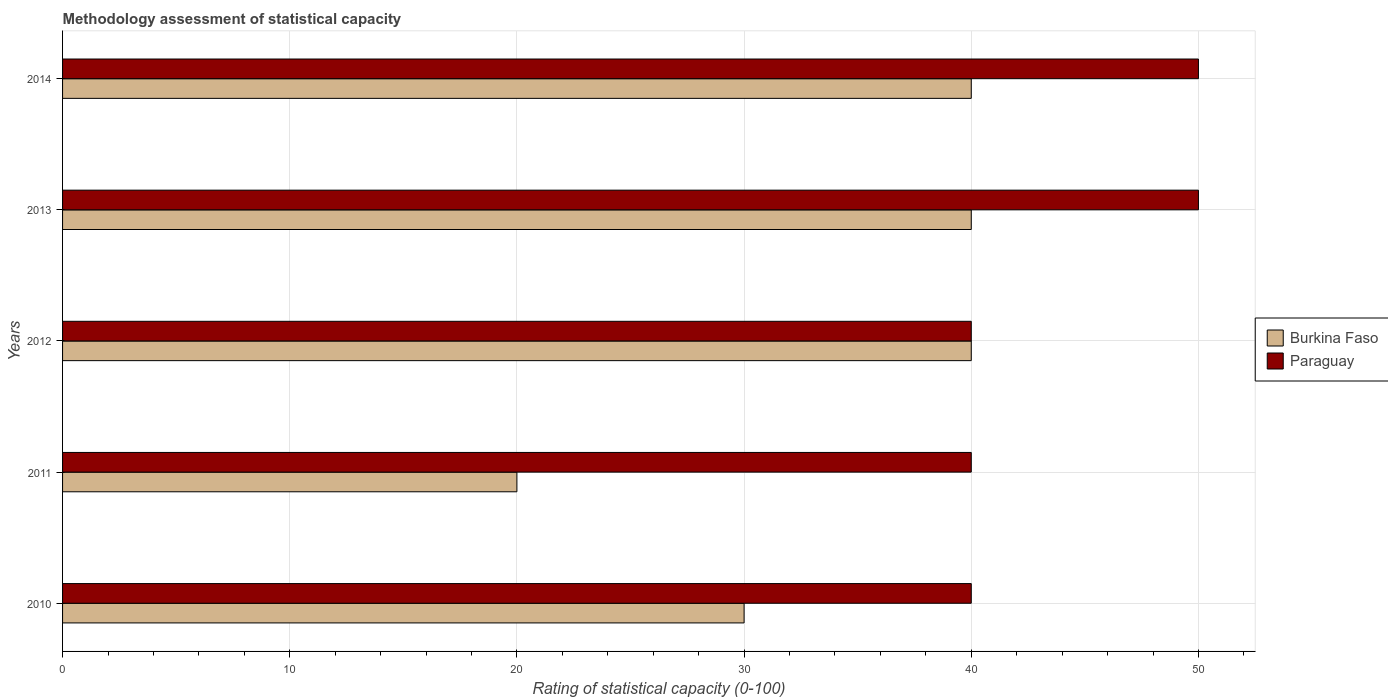Are the number of bars per tick equal to the number of legend labels?
Your answer should be very brief. Yes. Are the number of bars on each tick of the Y-axis equal?
Provide a succinct answer. Yes. How many bars are there on the 3rd tick from the bottom?
Your answer should be compact. 2. What is the label of the 2nd group of bars from the top?
Your answer should be very brief. 2013. What is the rating of statistical capacity in Paraguay in 2011?
Offer a terse response. 40. Across all years, what is the maximum rating of statistical capacity in Burkina Faso?
Your response must be concise. 40. Across all years, what is the minimum rating of statistical capacity in Burkina Faso?
Make the answer very short. 20. In which year was the rating of statistical capacity in Paraguay maximum?
Give a very brief answer. 2013. What is the total rating of statistical capacity in Paraguay in the graph?
Offer a very short reply. 220. What is the difference between the rating of statistical capacity in Paraguay in 2010 and that in 2014?
Provide a succinct answer. -10. What is the difference between the rating of statistical capacity in Paraguay in 2010 and the rating of statistical capacity in Burkina Faso in 2012?
Your response must be concise. 0. What is the average rating of statistical capacity in Paraguay per year?
Your response must be concise. 44. In the year 2013, what is the difference between the rating of statistical capacity in Paraguay and rating of statistical capacity in Burkina Faso?
Your response must be concise. 10. What is the ratio of the rating of statistical capacity in Burkina Faso in 2010 to that in 2014?
Provide a short and direct response. 0.75. Is the difference between the rating of statistical capacity in Paraguay in 2011 and 2013 greater than the difference between the rating of statistical capacity in Burkina Faso in 2011 and 2013?
Your answer should be compact. Yes. What is the difference between the highest and the second highest rating of statistical capacity in Burkina Faso?
Keep it short and to the point. 0. What is the difference between the highest and the lowest rating of statistical capacity in Paraguay?
Offer a very short reply. 10. Is the sum of the rating of statistical capacity in Paraguay in 2012 and 2013 greater than the maximum rating of statistical capacity in Burkina Faso across all years?
Offer a terse response. Yes. What does the 2nd bar from the top in 2014 represents?
Give a very brief answer. Burkina Faso. What does the 2nd bar from the bottom in 2014 represents?
Offer a very short reply. Paraguay. How many bars are there?
Make the answer very short. 10. How many years are there in the graph?
Your answer should be compact. 5. What is the difference between two consecutive major ticks on the X-axis?
Make the answer very short. 10. Are the values on the major ticks of X-axis written in scientific E-notation?
Your answer should be very brief. No. Does the graph contain any zero values?
Offer a terse response. No. What is the title of the graph?
Keep it short and to the point. Methodology assessment of statistical capacity. Does "United Kingdom" appear as one of the legend labels in the graph?
Your response must be concise. No. What is the label or title of the X-axis?
Provide a succinct answer. Rating of statistical capacity (0-100). What is the label or title of the Y-axis?
Give a very brief answer. Years. What is the Rating of statistical capacity (0-100) in Paraguay in 2010?
Offer a very short reply. 40. What is the Rating of statistical capacity (0-100) in Paraguay in 2011?
Your answer should be compact. 40. What is the Rating of statistical capacity (0-100) in Burkina Faso in 2012?
Your answer should be very brief. 40. What is the Rating of statistical capacity (0-100) of Paraguay in 2012?
Your response must be concise. 40. What is the Rating of statistical capacity (0-100) of Burkina Faso in 2014?
Ensure brevity in your answer.  40. Across all years, what is the maximum Rating of statistical capacity (0-100) of Burkina Faso?
Your response must be concise. 40. Across all years, what is the maximum Rating of statistical capacity (0-100) in Paraguay?
Your answer should be very brief. 50. What is the total Rating of statistical capacity (0-100) of Burkina Faso in the graph?
Your answer should be compact. 170. What is the total Rating of statistical capacity (0-100) in Paraguay in the graph?
Give a very brief answer. 220. What is the difference between the Rating of statistical capacity (0-100) of Paraguay in 2010 and that in 2011?
Give a very brief answer. 0. What is the difference between the Rating of statistical capacity (0-100) in Paraguay in 2010 and that in 2012?
Ensure brevity in your answer.  0. What is the difference between the Rating of statistical capacity (0-100) in Burkina Faso in 2010 and that in 2013?
Ensure brevity in your answer.  -10. What is the difference between the Rating of statistical capacity (0-100) in Paraguay in 2010 and that in 2014?
Offer a very short reply. -10. What is the difference between the Rating of statistical capacity (0-100) in Burkina Faso in 2011 and that in 2012?
Your response must be concise. -20. What is the difference between the Rating of statistical capacity (0-100) of Burkina Faso in 2012 and that in 2013?
Give a very brief answer. 0. What is the difference between the Rating of statistical capacity (0-100) of Burkina Faso in 2012 and that in 2014?
Ensure brevity in your answer.  0. What is the difference between the Rating of statistical capacity (0-100) in Burkina Faso in 2013 and that in 2014?
Provide a succinct answer. 0. What is the difference between the Rating of statistical capacity (0-100) of Burkina Faso in 2010 and the Rating of statistical capacity (0-100) of Paraguay in 2014?
Give a very brief answer. -20. What is the difference between the Rating of statistical capacity (0-100) of Burkina Faso in 2011 and the Rating of statistical capacity (0-100) of Paraguay in 2013?
Provide a short and direct response. -30. What is the difference between the Rating of statistical capacity (0-100) in Burkina Faso in 2012 and the Rating of statistical capacity (0-100) in Paraguay in 2014?
Keep it short and to the point. -10. What is the difference between the Rating of statistical capacity (0-100) in Burkina Faso in 2013 and the Rating of statistical capacity (0-100) in Paraguay in 2014?
Your answer should be very brief. -10. What is the average Rating of statistical capacity (0-100) of Burkina Faso per year?
Provide a short and direct response. 34. In the year 2011, what is the difference between the Rating of statistical capacity (0-100) in Burkina Faso and Rating of statistical capacity (0-100) in Paraguay?
Your answer should be very brief. -20. What is the ratio of the Rating of statistical capacity (0-100) in Burkina Faso in 2010 to that in 2011?
Ensure brevity in your answer.  1.5. What is the ratio of the Rating of statistical capacity (0-100) of Burkina Faso in 2010 to that in 2014?
Your answer should be compact. 0.75. What is the ratio of the Rating of statistical capacity (0-100) in Paraguay in 2010 to that in 2014?
Your response must be concise. 0.8. What is the ratio of the Rating of statistical capacity (0-100) of Burkina Faso in 2011 to that in 2012?
Your response must be concise. 0.5. What is the ratio of the Rating of statistical capacity (0-100) of Burkina Faso in 2011 to that in 2014?
Your answer should be compact. 0.5. What is the ratio of the Rating of statistical capacity (0-100) in Burkina Faso in 2013 to that in 2014?
Provide a succinct answer. 1. What is the ratio of the Rating of statistical capacity (0-100) of Paraguay in 2013 to that in 2014?
Give a very brief answer. 1. What is the difference between the highest and the second highest Rating of statistical capacity (0-100) in Paraguay?
Make the answer very short. 0. What is the difference between the highest and the lowest Rating of statistical capacity (0-100) of Burkina Faso?
Keep it short and to the point. 20. What is the difference between the highest and the lowest Rating of statistical capacity (0-100) in Paraguay?
Your answer should be compact. 10. 